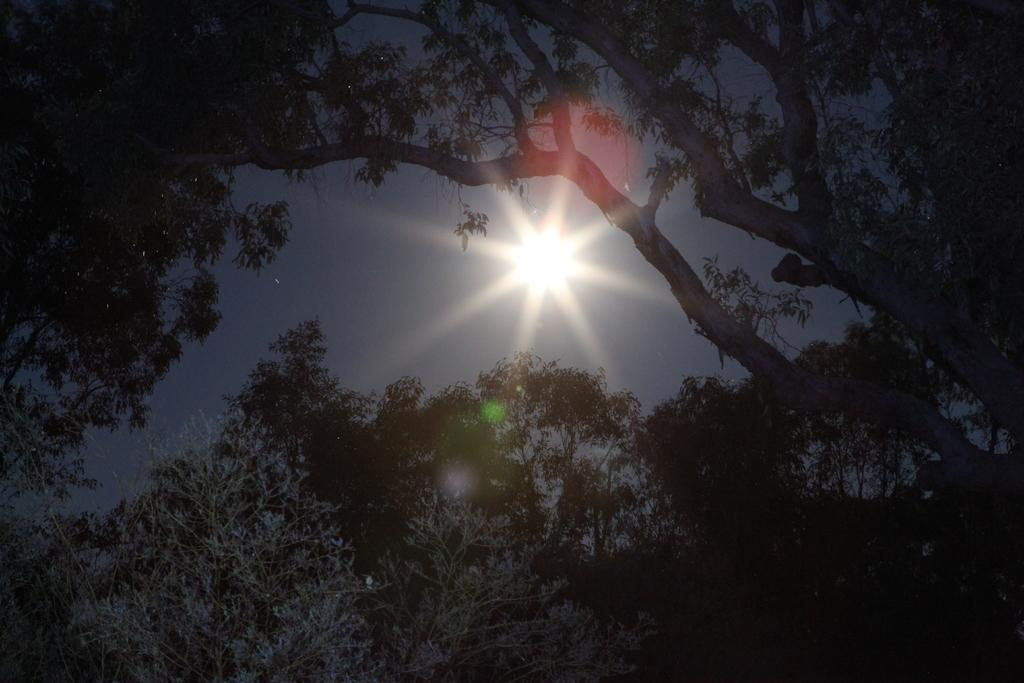What type of vegetation can be seen in the image? There are trees in the image. What is the condition of the sky in the image? The sky is clear in the image. Can the sun be seen in the image? Yes, the sun is visible in the image. What type of hen can be seen laying eggs in the image? There is no hen or eggs present in the image; it features trees and a clear sky. What color is the glove that is being used to paint the trees in the image? There is no glove or paint present in the image; it only features trees and a clear sky. 